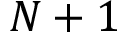<formula> <loc_0><loc_0><loc_500><loc_500>N + 1</formula> 